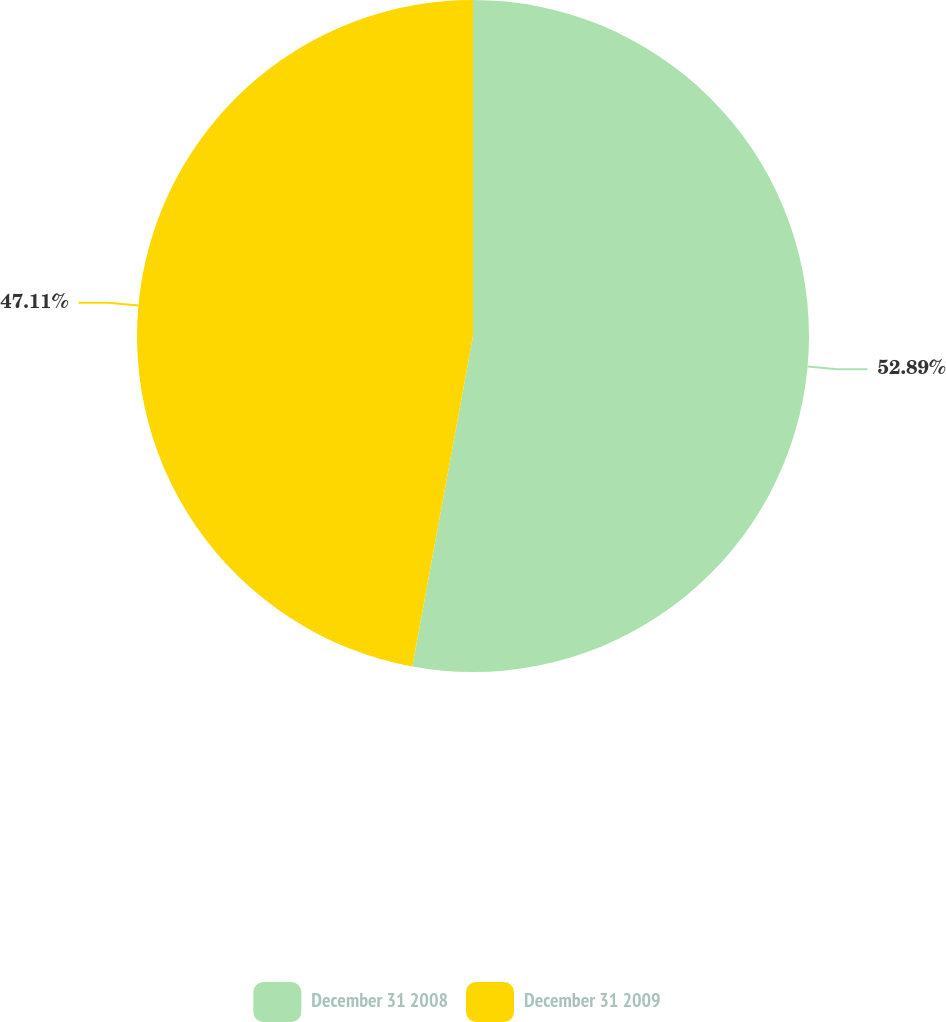<chart> <loc_0><loc_0><loc_500><loc_500><pie_chart><fcel>December 31 2008<fcel>December 31 2009<nl><fcel>52.89%<fcel>47.11%<nl></chart> 